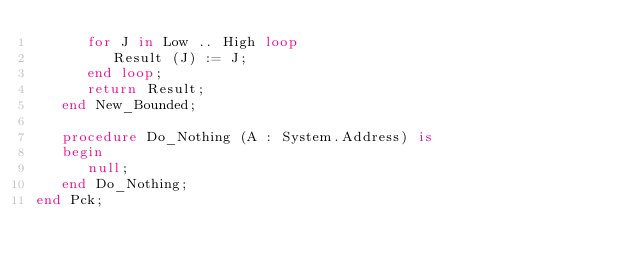Convert code to text. <code><loc_0><loc_0><loc_500><loc_500><_Ada_>      for J in Low .. High loop
         Result (J) := J;
      end loop;
      return Result;
   end New_Bounded;

   procedure Do_Nothing (A : System.Address) is
   begin
      null;
   end Do_Nothing;
end Pck;
</code> 